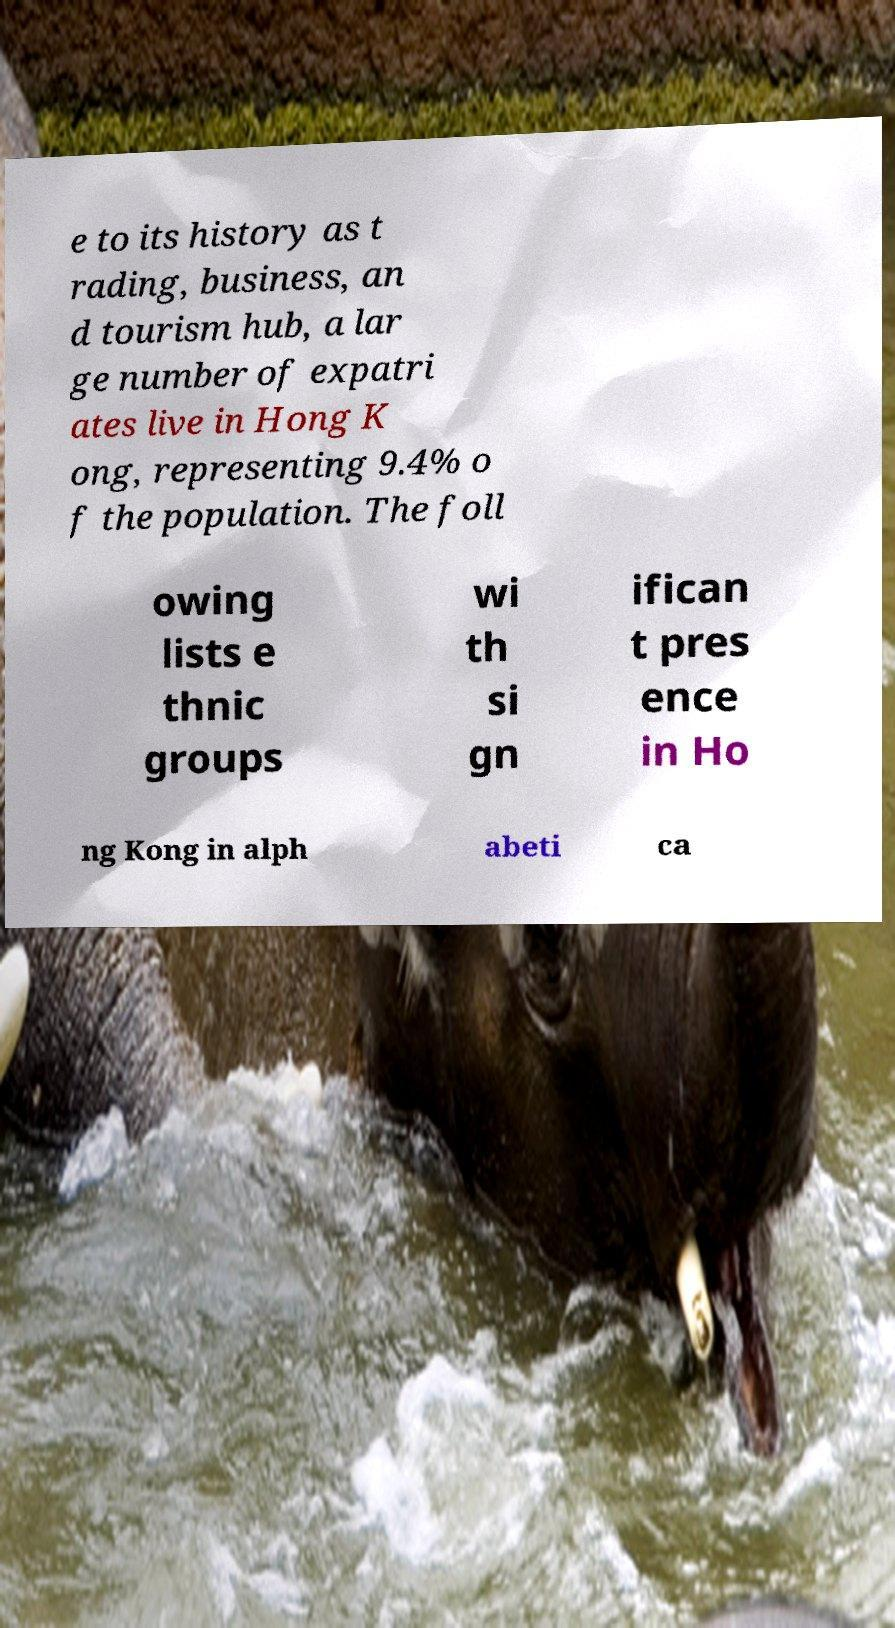Could you extract and type out the text from this image? e to its history as t rading, business, an d tourism hub, a lar ge number of expatri ates live in Hong K ong, representing 9.4% o f the population. The foll owing lists e thnic groups wi th si gn ifican t pres ence in Ho ng Kong in alph abeti ca 